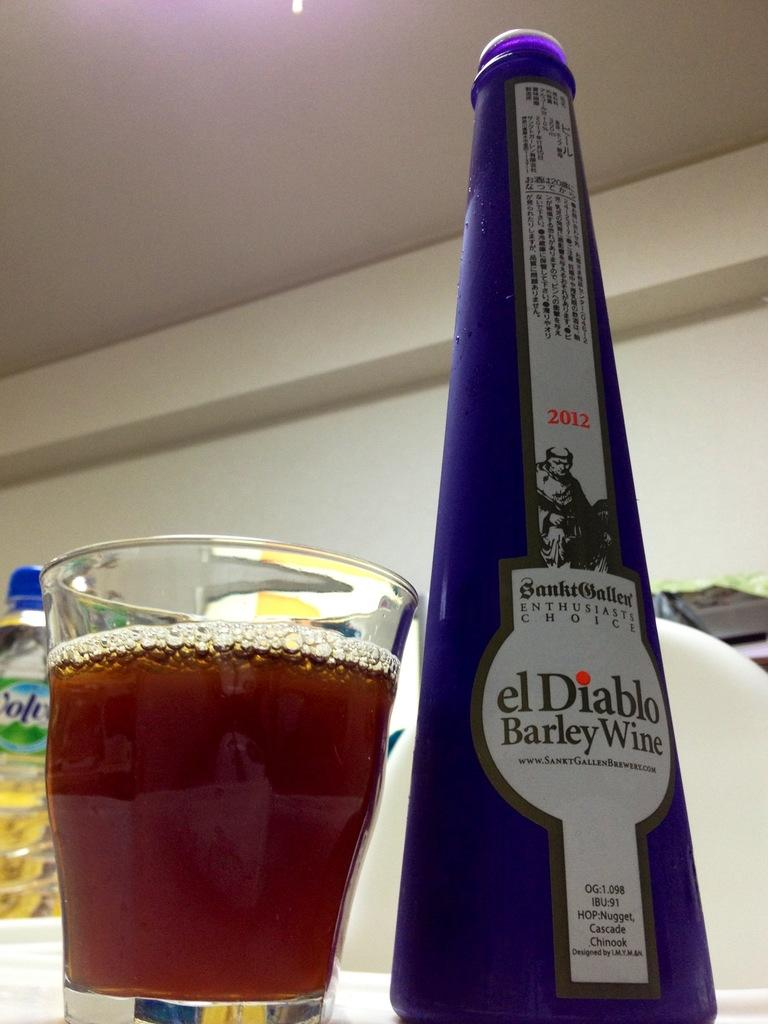<image>
Present a compact description of the photo's key features. A blue bottle of el Diablo Barley Wine next to a full glass. 